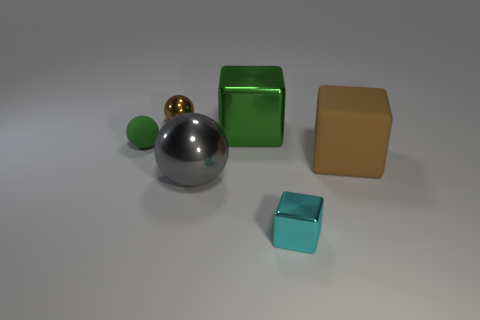Add 2 gray things. How many objects exist? 8 Subtract all large green metallic blocks. Subtract all small cyan shiny blocks. How many objects are left? 4 Add 1 small cubes. How many small cubes are left? 2 Add 1 green metallic objects. How many green metallic objects exist? 2 Subtract 0 cyan cylinders. How many objects are left? 6 